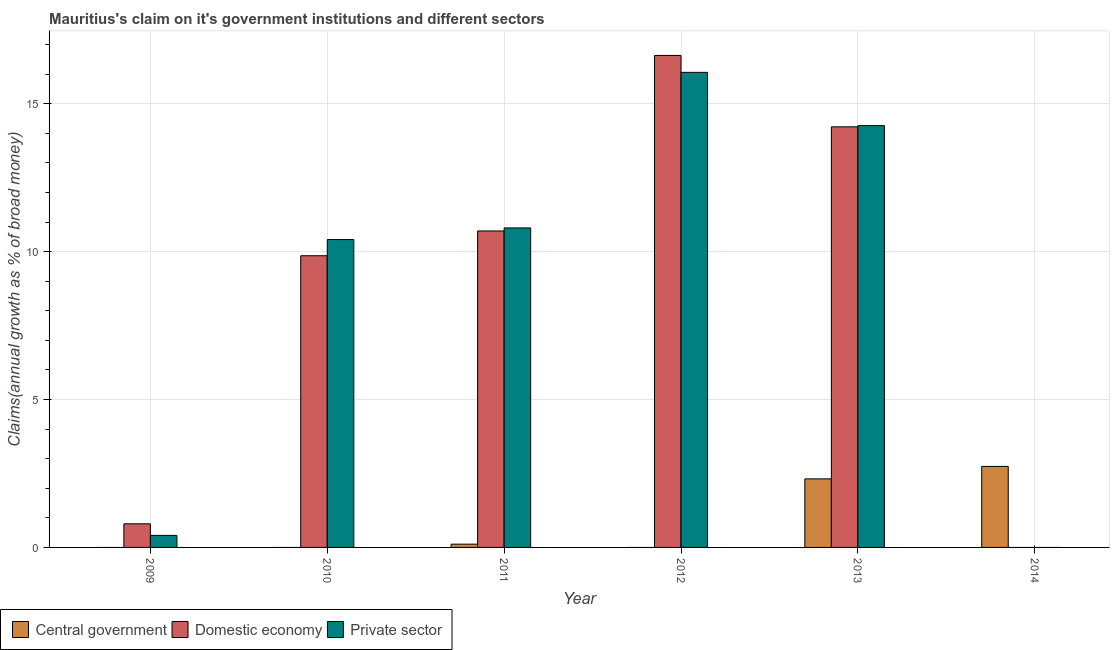How many different coloured bars are there?
Offer a terse response. 3. Are the number of bars per tick equal to the number of legend labels?
Offer a terse response. No. How many bars are there on the 2nd tick from the left?
Ensure brevity in your answer.  2. How many bars are there on the 4th tick from the right?
Keep it short and to the point. 3. In how many cases, is the number of bars for a given year not equal to the number of legend labels?
Make the answer very short. 4. What is the percentage of claim on the private sector in 2013?
Offer a terse response. 14.26. Across all years, what is the maximum percentage of claim on the private sector?
Your response must be concise. 16.06. What is the total percentage of claim on the private sector in the graph?
Your response must be concise. 51.93. What is the difference between the percentage of claim on the domestic economy in 2011 and that in 2012?
Offer a very short reply. -5.93. What is the difference between the percentage of claim on the domestic economy in 2014 and the percentage of claim on the private sector in 2012?
Your response must be concise. -16.63. What is the average percentage of claim on the domestic economy per year?
Keep it short and to the point. 8.7. In the year 2012, what is the difference between the percentage of claim on the domestic economy and percentage of claim on the private sector?
Provide a succinct answer. 0. What is the ratio of the percentage of claim on the central government in 2013 to that in 2014?
Your response must be concise. 0.85. Is the percentage of claim on the private sector in 2009 less than that in 2011?
Your answer should be compact. Yes. Is the difference between the percentage of claim on the private sector in 2012 and 2013 greater than the difference between the percentage of claim on the central government in 2012 and 2013?
Your answer should be very brief. No. What is the difference between the highest and the second highest percentage of claim on the private sector?
Ensure brevity in your answer.  1.8. What is the difference between the highest and the lowest percentage of claim on the private sector?
Your answer should be very brief. 16.06. In how many years, is the percentage of claim on the domestic economy greater than the average percentage of claim on the domestic economy taken over all years?
Provide a short and direct response. 4. How many bars are there?
Provide a succinct answer. 13. How many years are there in the graph?
Your answer should be compact. 6. Are the values on the major ticks of Y-axis written in scientific E-notation?
Offer a very short reply. No. Does the graph contain grids?
Your answer should be very brief. Yes. What is the title of the graph?
Your answer should be very brief. Mauritius's claim on it's government institutions and different sectors. Does "Spain" appear as one of the legend labels in the graph?
Offer a terse response. No. What is the label or title of the X-axis?
Provide a succinct answer. Year. What is the label or title of the Y-axis?
Keep it short and to the point. Claims(annual growth as % of broad money). What is the Claims(annual growth as % of broad money) of Central government in 2009?
Keep it short and to the point. 0. What is the Claims(annual growth as % of broad money) of Domestic economy in 2009?
Your response must be concise. 0.8. What is the Claims(annual growth as % of broad money) of Private sector in 2009?
Your answer should be very brief. 0.41. What is the Claims(annual growth as % of broad money) in Domestic economy in 2010?
Give a very brief answer. 9.86. What is the Claims(annual growth as % of broad money) of Private sector in 2010?
Provide a short and direct response. 10.41. What is the Claims(annual growth as % of broad money) in Central government in 2011?
Provide a succinct answer. 0.11. What is the Claims(annual growth as % of broad money) in Domestic economy in 2011?
Offer a very short reply. 10.7. What is the Claims(annual growth as % of broad money) in Private sector in 2011?
Give a very brief answer. 10.8. What is the Claims(annual growth as % of broad money) of Central government in 2012?
Your answer should be very brief. 0. What is the Claims(annual growth as % of broad money) of Domestic economy in 2012?
Your response must be concise. 16.63. What is the Claims(annual growth as % of broad money) in Private sector in 2012?
Provide a succinct answer. 16.06. What is the Claims(annual growth as % of broad money) in Central government in 2013?
Keep it short and to the point. 2.32. What is the Claims(annual growth as % of broad money) of Domestic economy in 2013?
Provide a succinct answer. 14.22. What is the Claims(annual growth as % of broad money) of Private sector in 2013?
Your answer should be very brief. 14.26. What is the Claims(annual growth as % of broad money) of Central government in 2014?
Ensure brevity in your answer.  2.74. What is the Claims(annual growth as % of broad money) of Domestic economy in 2014?
Make the answer very short. 0. Across all years, what is the maximum Claims(annual growth as % of broad money) in Central government?
Your answer should be very brief. 2.74. Across all years, what is the maximum Claims(annual growth as % of broad money) of Domestic economy?
Give a very brief answer. 16.63. Across all years, what is the maximum Claims(annual growth as % of broad money) in Private sector?
Your answer should be compact. 16.06. Across all years, what is the minimum Claims(annual growth as % of broad money) in Central government?
Ensure brevity in your answer.  0. Across all years, what is the minimum Claims(annual growth as % of broad money) of Domestic economy?
Offer a terse response. 0. What is the total Claims(annual growth as % of broad money) in Central government in the graph?
Your answer should be very brief. 5.17. What is the total Claims(annual growth as % of broad money) of Domestic economy in the graph?
Keep it short and to the point. 52.21. What is the total Claims(annual growth as % of broad money) in Private sector in the graph?
Make the answer very short. 51.93. What is the difference between the Claims(annual growth as % of broad money) in Domestic economy in 2009 and that in 2010?
Your answer should be very brief. -9.06. What is the difference between the Claims(annual growth as % of broad money) of Private sector in 2009 and that in 2010?
Your answer should be very brief. -10. What is the difference between the Claims(annual growth as % of broad money) of Domestic economy in 2009 and that in 2011?
Provide a short and direct response. -9.9. What is the difference between the Claims(annual growth as % of broad money) of Private sector in 2009 and that in 2011?
Offer a terse response. -10.39. What is the difference between the Claims(annual growth as % of broad money) of Domestic economy in 2009 and that in 2012?
Offer a terse response. -15.83. What is the difference between the Claims(annual growth as % of broad money) in Private sector in 2009 and that in 2012?
Keep it short and to the point. -15.65. What is the difference between the Claims(annual growth as % of broad money) in Domestic economy in 2009 and that in 2013?
Provide a succinct answer. -13.42. What is the difference between the Claims(annual growth as % of broad money) in Private sector in 2009 and that in 2013?
Give a very brief answer. -13.85. What is the difference between the Claims(annual growth as % of broad money) of Domestic economy in 2010 and that in 2011?
Offer a very short reply. -0.84. What is the difference between the Claims(annual growth as % of broad money) in Private sector in 2010 and that in 2011?
Provide a short and direct response. -0.39. What is the difference between the Claims(annual growth as % of broad money) in Domestic economy in 2010 and that in 2012?
Offer a terse response. -6.77. What is the difference between the Claims(annual growth as % of broad money) in Private sector in 2010 and that in 2012?
Offer a terse response. -5.65. What is the difference between the Claims(annual growth as % of broad money) in Domestic economy in 2010 and that in 2013?
Make the answer very short. -4.36. What is the difference between the Claims(annual growth as % of broad money) of Private sector in 2010 and that in 2013?
Ensure brevity in your answer.  -3.85. What is the difference between the Claims(annual growth as % of broad money) of Domestic economy in 2011 and that in 2012?
Your response must be concise. -5.93. What is the difference between the Claims(annual growth as % of broad money) of Private sector in 2011 and that in 2012?
Your answer should be very brief. -5.26. What is the difference between the Claims(annual growth as % of broad money) of Central government in 2011 and that in 2013?
Provide a succinct answer. -2.21. What is the difference between the Claims(annual growth as % of broad money) in Domestic economy in 2011 and that in 2013?
Your response must be concise. -3.52. What is the difference between the Claims(annual growth as % of broad money) of Private sector in 2011 and that in 2013?
Offer a very short reply. -3.46. What is the difference between the Claims(annual growth as % of broad money) in Central government in 2011 and that in 2014?
Make the answer very short. -2.63. What is the difference between the Claims(annual growth as % of broad money) of Domestic economy in 2012 and that in 2013?
Offer a terse response. 2.41. What is the difference between the Claims(annual growth as % of broad money) in Private sector in 2012 and that in 2013?
Your response must be concise. 1.8. What is the difference between the Claims(annual growth as % of broad money) in Central government in 2013 and that in 2014?
Give a very brief answer. -0.42. What is the difference between the Claims(annual growth as % of broad money) in Domestic economy in 2009 and the Claims(annual growth as % of broad money) in Private sector in 2010?
Ensure brevity in your answer.  -9.61. What is the difference between the Claims(annual growth as % of broad money) of Domestic economy in 2009 and the Claims(annual growth as % of broad money) of Private sector in 2011?
Offer a very short reply. -10. What is the difference between the Claims(annual growth as % of broad money) in Domestic economy in 2009 and the Claims(annual growth as % of broad money) in Private sector in 2012?
Offer a terse response. -15.26. What is the difference between the Claims(annual growth as % of broad money) in Domestic economy in 2009 and the Claims(annual growth as % of broad money) in Private sector in 2013?
Offer a terse response. -13.46. What is the difference between the Claims(annual growth as % of broad money) of Domestic economy in 2010 and the Claims(annual growth as % of broad money) of Private sector in 2011?
Make the answer very short. -0.94. What is the difference between the Claims(annual growth as % of broad money) in Domestic economy in 2010 and the Claims(annual growth as % of broad money) in Private sector in 2012?
Keep it short and to the point. -6.2. What is the difference between the Claims(annual growth as % of broad money) of Domestic economy in 2010 and the Claims(annual growth as % of broad money) of Private sector in 2013?
Keep it short and to the point. -4.4. What is the difference between the Claims(annual growth as % of broad money) of Central government in 2011 and the Claims(annual growth as % of broad money) of Domestic economy in 2012?
Offer a very short reply. -16.52. What is the difference between the Claims(annual growth as % of broad money) in Central government in 2011 and the Claims(annual growth as % of broad money) in Private sector in 2012?
Make the answer very short. -15.95. What is the difference between the Claims(annual growth as % of broad money) of Domestic economy in 2011 and the Claims(annual growth as % of broad money) of Private sector in 2012?
Your answer should be compact. -5.36. What is the difference between the Claims(annual growth as % of broad money) in Central government in 2011 and the Claims(annual growth as % of broad money) in Domestic economy in 2013?
Make the answer very short. -14.11. What is the difference between the Claims(annual growth as % of broad money) of Central government in 2011 and the Claims(annual growth as % of broad money) of Private sector in 2013?
Ensure brevity in your answer.  -14.15. What is the difference between the Claims(annual growth as % of broad money) in Domestic economy in 2011 and the Claims(annual growth as % of broad money) in Private sector in 2013?
Your answer should be compact. -3.56. What is the difference between the Claims(annual growth as % of broad money) of Domestic economy in 2012 and the Claims(annual growth as % of broad money) of Private sector in 2013?
Provide a short and direct response. 2.37. What is the average Claims(annual growth as % of broad money) in Central government per year?
Your response must be concise. 0.86. What is the average Claims(annual growth as % of broad money) of Domestic economy per year?
Provide a succinct answer. 8.7. What is the average Claims(annual growth as % of broad money) of Private sector per year?
Offer a very short reply. 8.66. In the year 2009, what is the difference between the Claims(annual growth as % of broad money) in Domestic economy and Claims(annual growth as % of broad money) in Private sector?
Offer a very short reply. 0.39. In the year 2010, what is the difference between the Claims(annual growth as % of broad money) in Domestic economy and Claims(annual growth as % of broad money) in Private sector?
Your response must be concise. -0.55. In the year 2011, what is the difference between the Claims(annual growth as % of broad money) of Central government and Claims(annual growth as % of broad money) of Domestic economy?
Offer a terse response. -10.59. In the year 2011, what is the difference between the Claims(annual growth as % of broad money) in Central government and Claims(annual growth as % of broad money) in Private sector?
Provide a succinct answer. -10.69. In the year 2011, what is the difference between the Claims(annual growth as % of broad money) of Domestic economy and Claims(annual growth as % of broad money) of Private sector?
Your answer should be compact. -0.1. In the year 2012, what is the difference between the Claims(annual growth as % of broad money) in Domestic economy and Claims(annual growth as % of broad money) in Private sector?
Give a very brief answer. 0.57. In the year 2013, what is the difference between the Claims(annual growth as % of broad money) in Central government and Claims(annual growth as % of broad money) in Domestic economy?
Provide a succinct answer. -11.9. In the year 2013, what is the difference between the Claims(annual growth as % of broad money) of Central government and Claims(annual growth as % of broad money) of Private sector?
Provide a succinct answer. -11.94. In the year 2013, what is the difference between the Claims(annual growth as % of broad money) in Domestic economy and Claims(annual growth as % of broad money) in Private sector?
Your answer should be very brief. -0.04. What is the ratio of the Claims(annual growth as % of broad money) of Domestic economy in 2009 to that in 2010?
Ensure brevity in your answer.  0.08. What is the ratio of the Claims(annual growth as % of broad money) in Private sector in 2009 to that in 2010?
Give a very brief answer. 0.04. What is the ratio of the Claims(annual growth as % of broad money) in Domestic economy in 2009 to that in 2011?
Offer a terse response. 0.07. What is the ratio of the Claims(annual growth as % of broad money) of Private sector in 2009 to that in 2011?
Your answer should be very brief. 0.04. What is the ratio of the Claims(annual growth as % of broad money) in Domestic economy in 2009 to that in 2012?
Give a very brief answer. 0.05. What is the ratio of the Claims(annual growth as % of broad money) of Private sector in 2009 to that in 2012?
Offer a very short reply. 0.03. What is the ratio of the Claims(annual growth as % of broad money) in Domestic economy in 2009 to that in 2013?
Provide a succinct answer. 0.06. What is the ratio of the Claims(annual growth as % of broad money) in Private sector in 2009 to that in 2013?
Your answer should be compact. 0.03. What is the ratio of the Claims(annual growth as % of broad money) in Domestic economy in 2010 to that in 2011?
Provide a succinct answer. 0.92. What is the ratio of the Claims(annual growth as % of broad money) of Private sector in 2010 to that in 2011?
Your response must be concise. 0.96. What is the ratio of the Claims(annual growth as % of broad money) in Domestic economy in 2010 to that in 2012?
Keep it short and to the point. 0.59. What is the ratio of the Claims(annual growth as % of broad money) of Private sector in 2010 to that in 2012?
Offer a terse response. 0.65. What is the ratio of the Claims(annual growth as % of broad money) in Domestic economy in 2010 to that in 2013?
Provide a short and direct response. 0.69. What is the ratio of the Claims(annual growth as % of broad money) in Private sector in 2010 to that in 2013?
Keep it short and to the point. 0.73. What is the ratio of the Claims(annual growth as % of broad money) in Domestic economy in 2011 to that in 2012?
Ensure brevity in your answer.  0.64. What is the ratio of the Claims(annual growth as % of broad money) in Private sector in 2011 to that in 2012?
Provide a succinct answer. 0.67. What is the ratio of the Claims(annual growth as % of broad money) of Central government in 2011 to that in 2013?
Offer a terse response. 0.05. What is the ratio of the Claims(annual growth as % of broad money) in Domestic economy in 2011 to that in 2013?
Offer a terse response. 0.75. What is the ratio of the Claims(annual growth as % of broad money) in Private sector in 2011 to that in 2013?
Provide a succinct answer. 0.76. What is the ratio of the Claims(annual growth as % of broad money) in Central government in 2011 to that in 2014?
Offer a very short reply. 0.04. What is the ratio of the Claims(annual growth as % of broad money) in Domestic economy in 2012 to that in 2013?
Ensure brevity in your answer.  1.17. What is the ratio of the Claims(annual growth as % of broad money) in Private sector in 2012 to that in 2013?
Your answer should be compact. 1.13. What is the ratio of the Claims(annual growth as % of broad money) in Central government in 2013 to that in 2014?
Give a very brief answer. 0.85. What is the difference between the highest and the second highest Claims(annual growth as % of broad money) of Central government?
Provide a short and direct response. 0.42. What is the difference between the highest and the second highest Claims(annual growth as % of broad money) of Domestic economy?
Offer a terse response. 2.41. What is the difference between the highest and the second highest Claims(annual growth as % of broad money) of Private sector?
Offer a terse response. 1.8. What is the difference between the highest and the lowest Claims(annual growth as % of broad money) of Central government?
Offer a terse response. 2.74. What is the difference between the highest and the lowest Claims(annual growth as % of broad money) in Domestic economy?
Make the answer very short. 16.63. What is the difference between the highest and the lowest Claims(annual growth as % of broad money) in Private sector?
Offer a terse response. 16.06. 